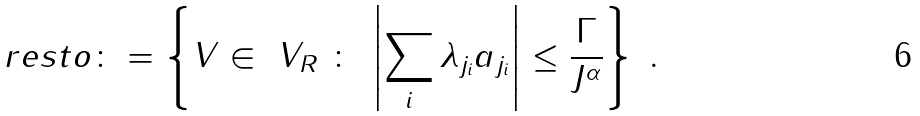Convert formula to latex. <formula><loc_0><loc_0><loc_500><loc_500>\ r e s t o \colon = \left \{ V \in \ V _ { R } \ \colon \ \left | \sum _ { i } \lambda _ { j _ { i } } a _ { j _ { i } } \right | \leq \frac { \Gamma } { J ^ { \alpha } } \right \} \ .</formula> 